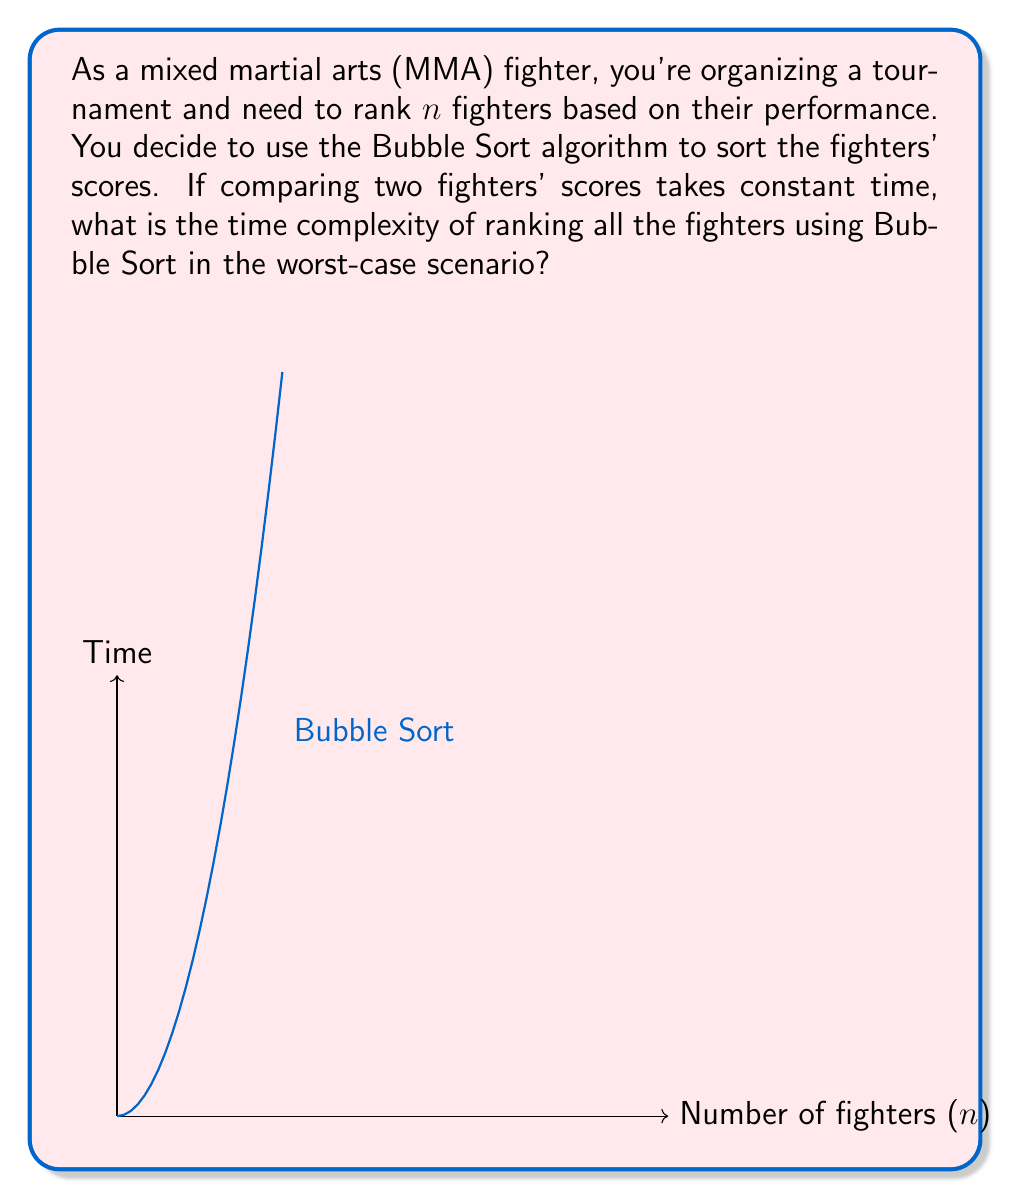Provide a solution to this math problem. Let's analyze the time complexity of Bubble Sort for ranking $n$ fighters:

1) Bubble Sort works by repeatedly stepping through the list, comparing adjacent elements and swapping them if they're in the wrong order.

2) In the worst-case scenario (when the list is in reverse order):
   - First pass: $(n-1)$ comparisons
   - Second pass: $(n-2)$ comparisons
   - Third pass: $(n-3)$ comparisons
   ...
   - Last pass: $1$ comparison

3) The total number of comparisons is the sum of the first $(n-1)$ positive integers:

   $$(n-1) + (n-2) + (n-3) + ... + 2 + 1$$

4) This sum can be represented by the formula:

   $$\sum_{i=1}^{n-1} i = \frac{n(n-1)}{2}$$

5) Expanding this:

   $$\frac{n^2 - n}{2}$$

6) In Big O notation, we ignore lower-order terms and constants. Therefore:

   $$O(\frac{n^2 - n}{2}) = O(n^2)$$

7) Each comparison takes constant time, so the overall time complexity remains $O(n^2)$.

The graph in the question illustrates how the time increases quadratically with the number of fighters, which is characteristic of $O(n^2)$ algorithms.
Answer: $O(n^2)$ 